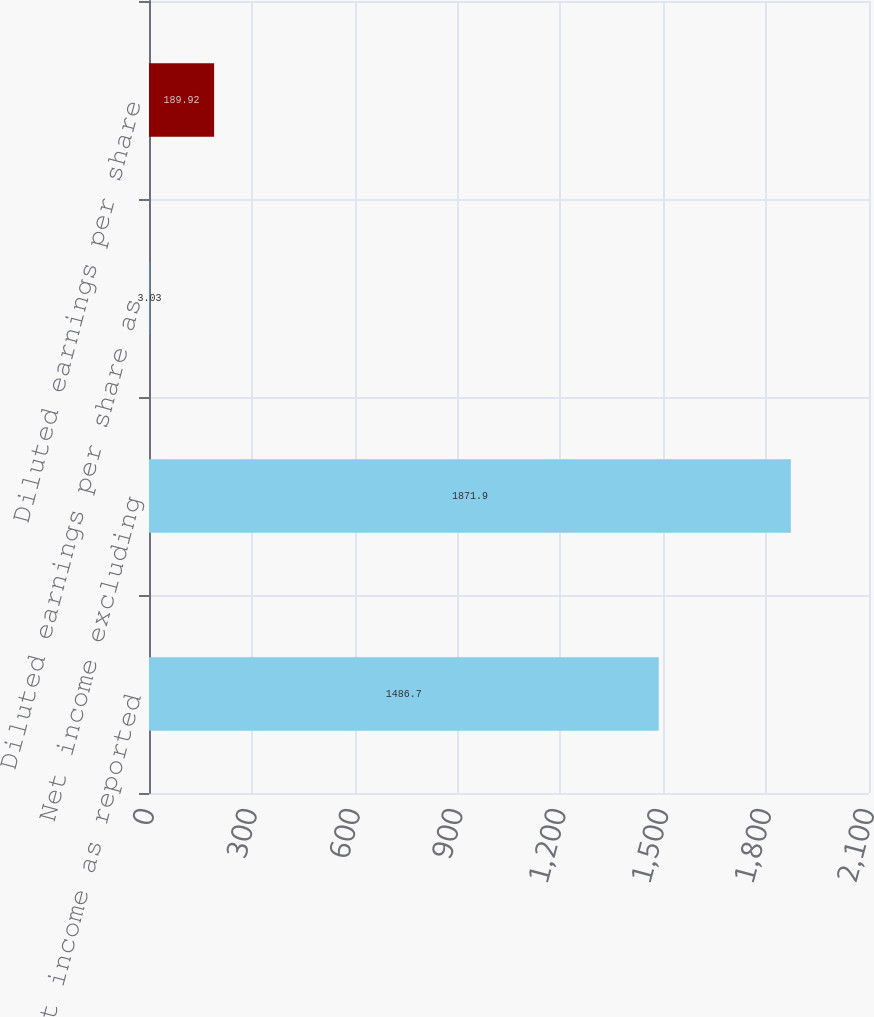Convert chart to OTSL. <chart><loc_0><loc_0><loc_500><loc_500><bar_chart><fcel>Net income as reported<fcel>Net income excluding<fcel>Diluted earnings per share as<fcel>Diluted earnings per share<nl><fcel>1486.7<fcel>1871.9<fcel>3.03<fcel>189.92<nl></chart> 